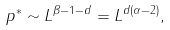<formula> <loc_0><loc_0><loc_500><loc_500>p ^ { * } \sim L ^ { \beta - 1 - d } = L ^ { d ( \alpha - 2 ) } ,</formula> 